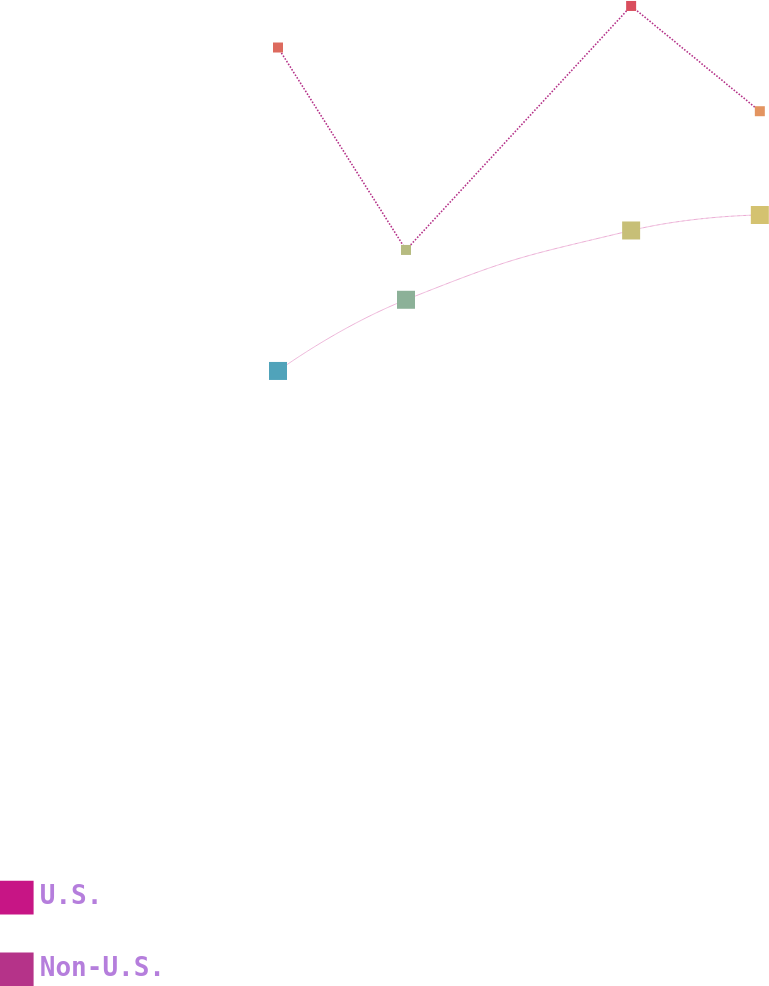<chart> <loc_0><loc_0><loc_500><loc_500><line_chart><ecel><fcel>U.S.<fcel>Non-U.S.<nl><fcel>1838.58<fcel>9469.57<fcel>15534.3<nl><fcel>1891.44<fcel>10804.2<fcel>11738.5<nl><fcel>1984.42<fcel>12103.5<fcel>16313.3<nl><fcel>2037.57<fcel>12393.5<fcel>14339.8<nl><fcel>2367.21<fcel>11706.4<fcel>13859.3<nl></chart> 